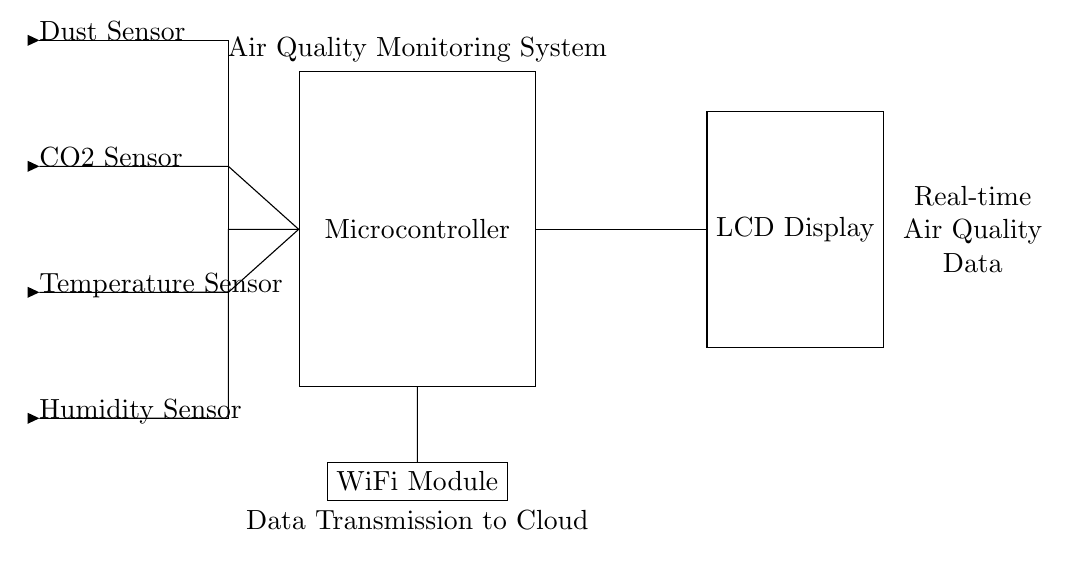What sensors are included in this system? The diagram shows four sensors: a Dust Sensor, a CO2 Sensor, a Temperature Sensor, and a Humidity Sensor, all depicted as input arrows at the left side of the circuit.
Answer: Dust Sensor, CO2 Sensor, Temperature Sensor, Humidity Sensor What is the function of the microcontroller in this circuit? The microcontroller acts as the central processing unit that receives data from all the sensors and processes it for display and transmission. Its role is fundamental in managing the data flow within the system.
Answer: Central processing unit How are the sensors connected to the microcontroller? The sensors are connected to the microcontroller using wires depicted in the circuit, which indicate the flow of information from each sensor leading to the microcontroller on the right side.
Answer: Using wires Which component displays the processed air quality data? The processed air quality data is displayed on an LCD Display, which is connected to the microcontroller on the right side of the circuit, indicating visual feedback of the data.
Answer: LCD Display What is the purpose of the WiFi module in this system? The WiFi module is used for data transmission to the cloud, indicated by its connection to the microcontroller. This allows for remote monitoring and data analysis outside of the classroom.
Answer: Data transmission to the cloud What type of system is being represented by this circuit? This circuit represents a digital air quality monitoring system designed for classrooms, as indicated by the components and their functions aimed at measuring and displaying air quality.
Answer: Digital air quality monitoring system 